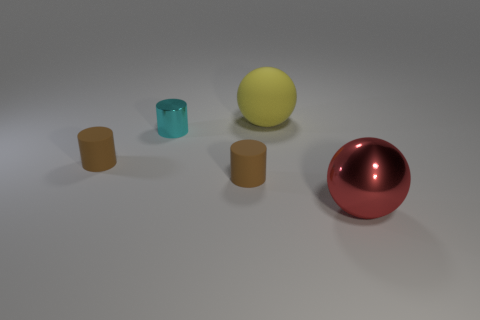Subtract all cyan metallic cylinders. How many cylinders are left? 2 Add 1 tiny cyan shiny cylinders. How many objects exist? 6 Subtract all cyan cylinders. How many cylinders are left? 2 Subtract all spheres. How many objects are left? 3 Subtract 3 cylinders. How many cylinders are left? 0 Add 4 metallic cylinders. How many metallic cylinders are left? 5 Add 1 yellow matte spheres. How many yellow matte spheres exist? 2 Subtract 0 green blocks. How many objects are left? 5 Subtract all blue balls. Subtract all green blocks. How many balls are left? 2 Subtract all brown cylinders. How many green balls are left? 0 